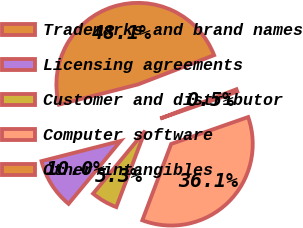Convert chart. <chart><loc_0><loc_0><loc_500><loc_500><pie_chart><fcel>Trademarks and brand names<fcel>Licensing agreements<fcel>Customer and distributor<fcel>Computer software<fcel>Other intangibles<nl><fcel>48.14%<fcel>10.02%<fcel>5.26%<fcel>36.1%<fcel>0.49%<nl></chart> 